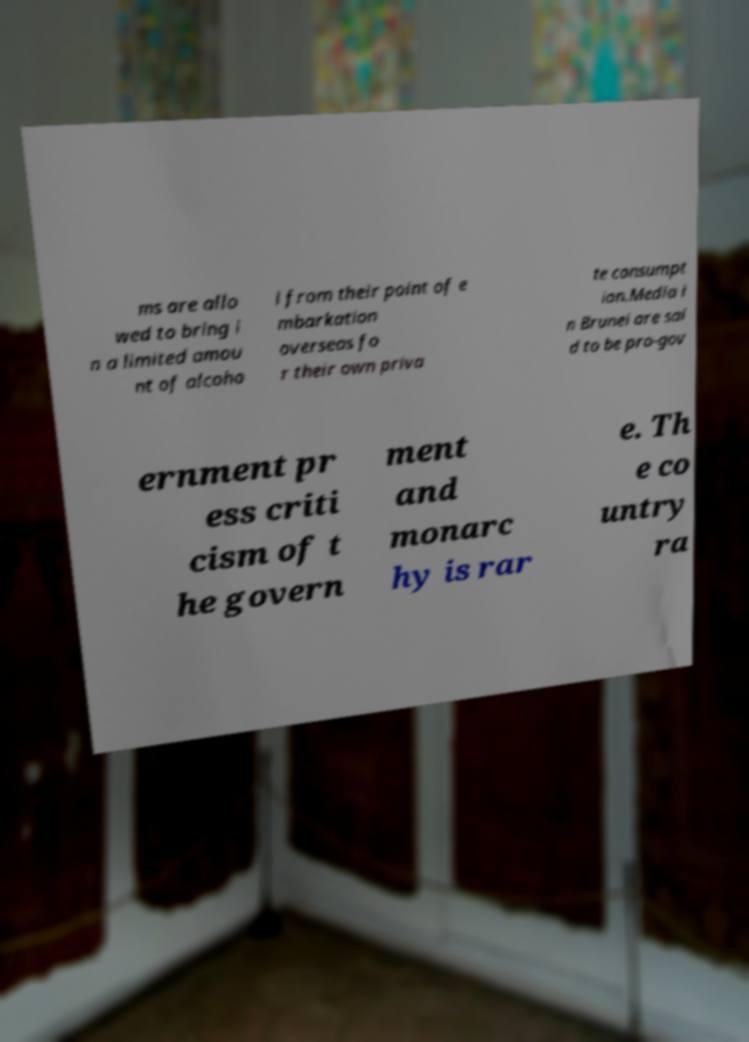There's text embedded in this image that I need extracted. Can you transcribe it verbatim? ms are allo wed to bring i n a limited amou nt of alcoho l from their point of e mbarkation overseas fo r their own priva te consumpt ion.Media i n Brunei are sai d to be pro-gov ernment pr ess criti cism of t he govern ment and monarc hy is rar e. Th e co untry ra 